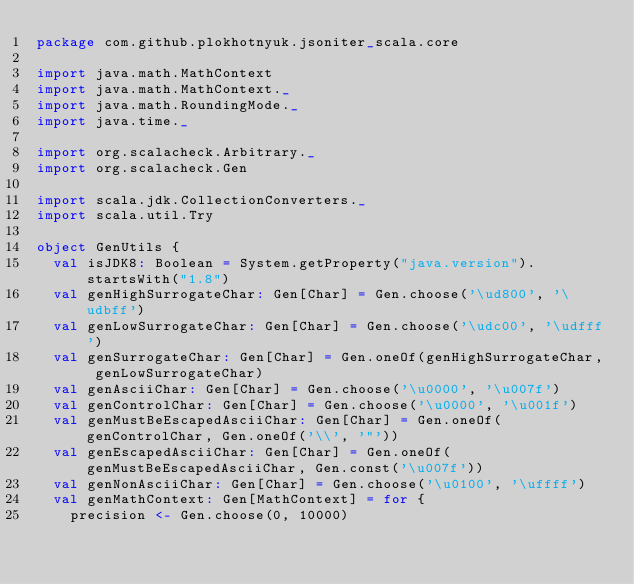<code> <loc_0><loc_0><loc_500><loc_500><_Scala_>package com.github.plokhotnyuk.jsoniter_scala.core

import java.math.MathContext
import java.math.MathContext._
import java.math.RoundingMode._
import java.time._

import org.scalacheck.Arbitrary._
import org.scalacheck.Gen

import scala.jdk.CollectionConverters._
import scala.util.Try

object GenUtils {
  val isJDK8: Boolean = System.getProperty("java.version").startsWith("1.8")
  val genHighSurrogateChar: Gen[Char] = Gen.choose('\ud800', '\udbff')
  val genLowSurrogateChar: Gen[Char] = Gen.choose('\udc00', '\udfff')
  val genSurrogateChar: Gen[Char] = Gen.oneOf(genHighSurrogateChar, genLowSurrogateChar)
  val genAsciiChar: Gen[Char] = Gen.choose('\u0000', '\u007f')
  val genControlChar: Gen[Char] = Gen.choose('\u0000', '\u001f')
  val genMustBeEscapedAsciiChar: Gen[Char] = Gen.oneOf(genControlChar, Gen.oneOf('\\', '"'))
  val genEscapedAsciiChar: Gen[Char] = Gen.oneOf(genMustBeEscapedAsciiChar, Gen.const('\u007f'))
  val genNonAsciiChar: Gen[Char] = Gen.choose('\u0100', '\uffff')
  val genMathContext: Gen[MathContext] = for {
    precision <- Gen.choose(0, 10000)</code> 